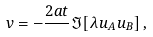<formula> <loc_0><loc_0><loc_500><loc_500>v = - \frac { 2 a t } { } \Im [ \lambda u _ { A } u _ { B } ] \, ,</formula> 